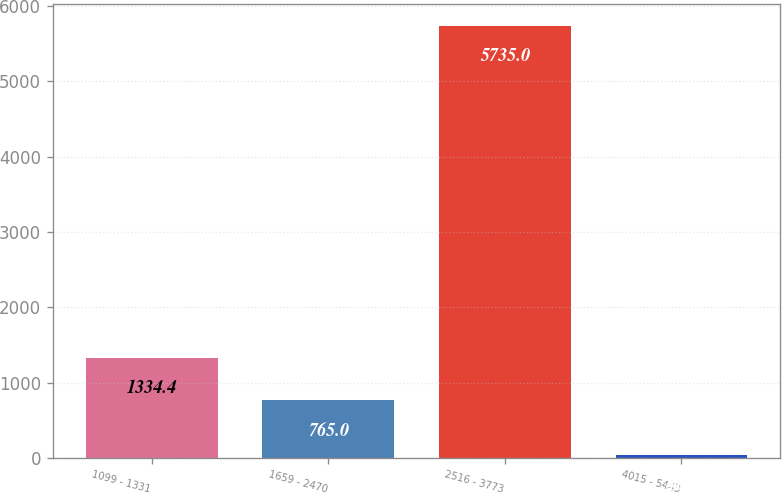Convert chart. <chart><loc_0><loc_0><loc_500><loc_500><bar_chart><fcel>1099 - 1331<fcel>1659 - 2470<fcel>2516 - 3773<fcel>4015 - 5443<nl><fcel>1334.4<fcel>765<fcel>5735<fcel>41<nl></chart> 